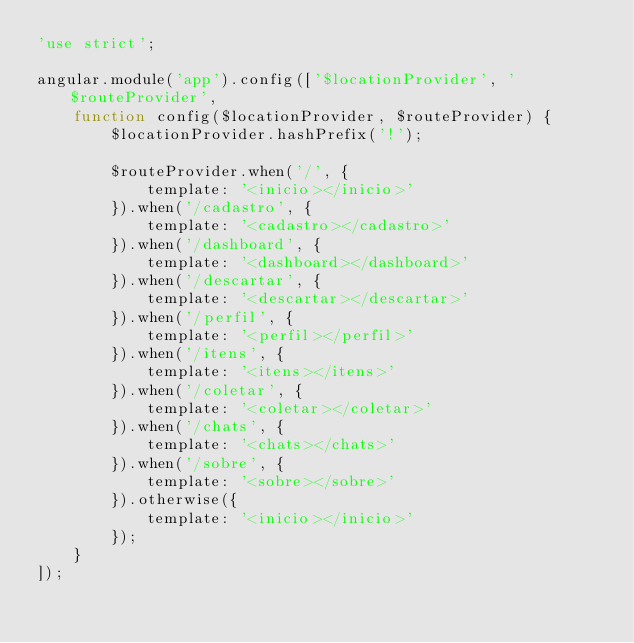Convert code to text. <code><loc_0><loc_0><loc_500><loc_500><_JavaScript_>'use strict';

angular.module('app').config(['$locationProvider', '$routeProvider',
    function config($locationProvider, $routeProvider) {
        $locationProvider.hashPrefix('!');

        $routeProvider.when('/', {
            template: '<inicio></inicio>'
        }).when('/cadastro', {
            template: '<cadastro></cadastro>'
        }).when('/dashboard', {
            template: '<dashboard></dashboard>'
        }).when('/descartar', {
            template: '<descartar></descartar>'
        }).when('/perfil', {
            template: '<perfil></perfil>'
        }).when('/itens', {
            template: '<itens></itens>'
        }).when('/coletar', {
            template: '<coletar></coletar>'
        }).when('/chats', {
            template: '<chats></chats>'
        }).when('/sobre', {
            template: '<sobre></sobre>'
        }).otherwise({
            template: '<inicio></inicio>'
        });
    }
]);
</code> 